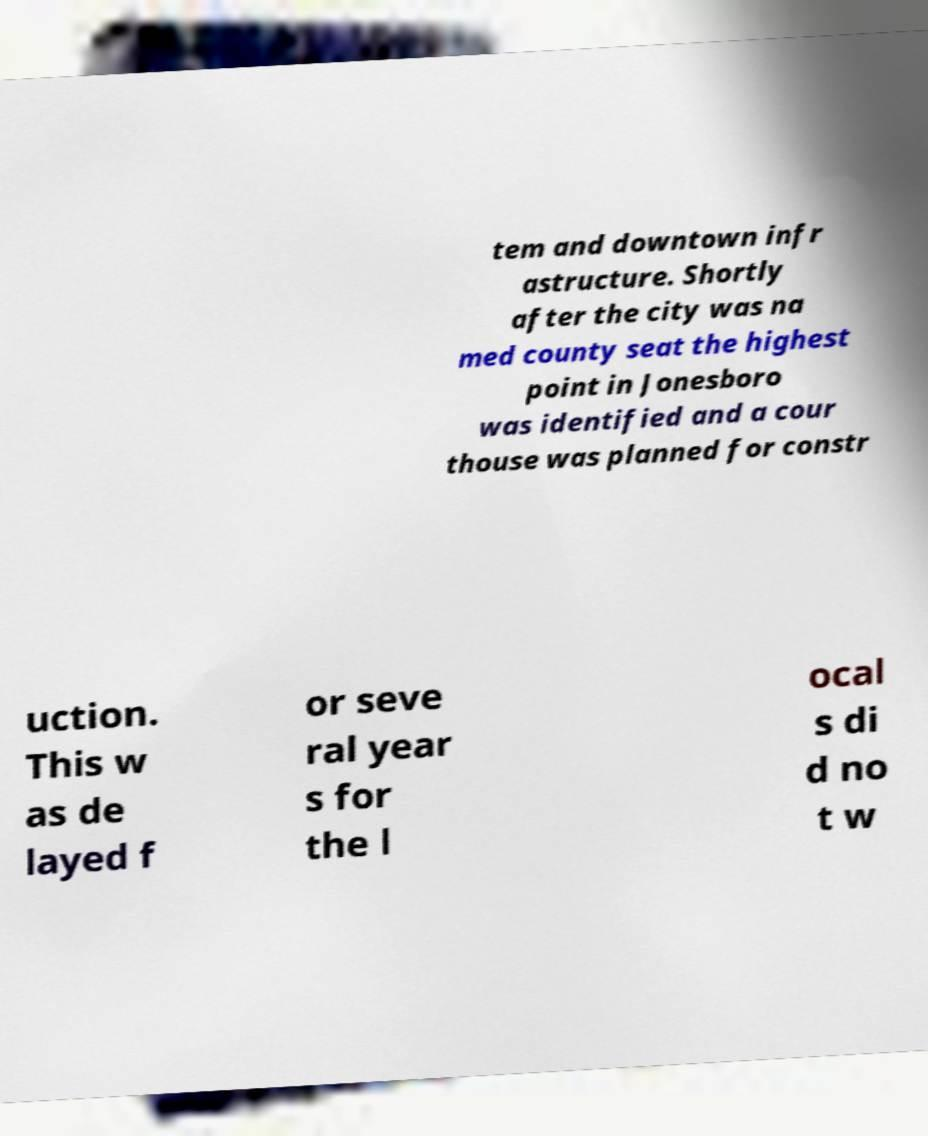Can you read and provide the text displayed in the image?This photo seems to have some interesting text. Can you extract and type it out for me? tem and downtown infr astructure. Shortly after the city was na med county seat the highest point in Jonesboro was identified and a cour thouse was planned for constr uction. This w as de layed f or seve ral year s for the l ocal s di d no t w 